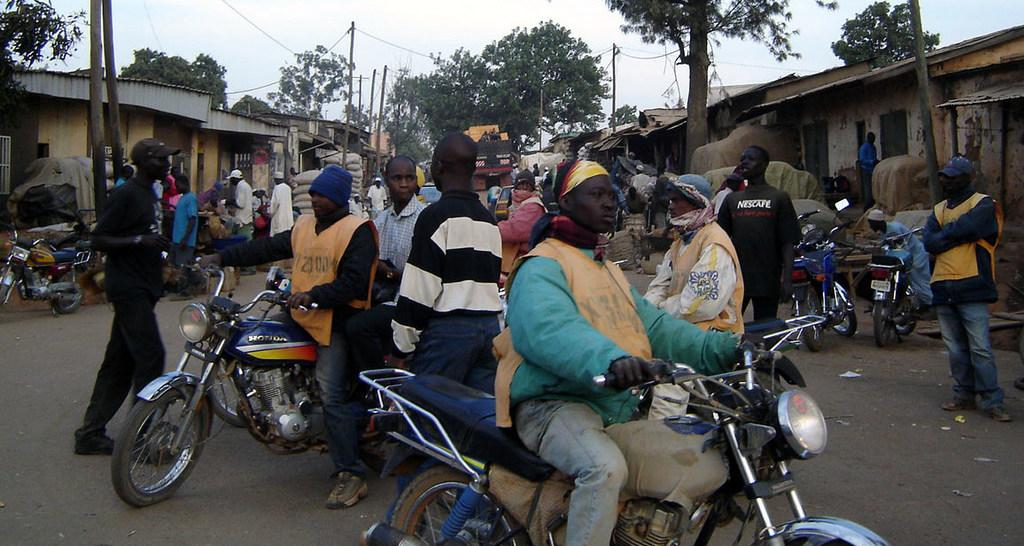What are the people doing in the image? There are people on a bike in the image. What can be seen in the background of the image? There is a building, a tree, and the sky visible in the background of the image. What else is present in the background of the image? There is a pole in the background of the image. What type of wilderness can be seen in the image? There is no wilderness present in the image; it features a bike with people riding it and a background with a building, tree, sky, and pole. 